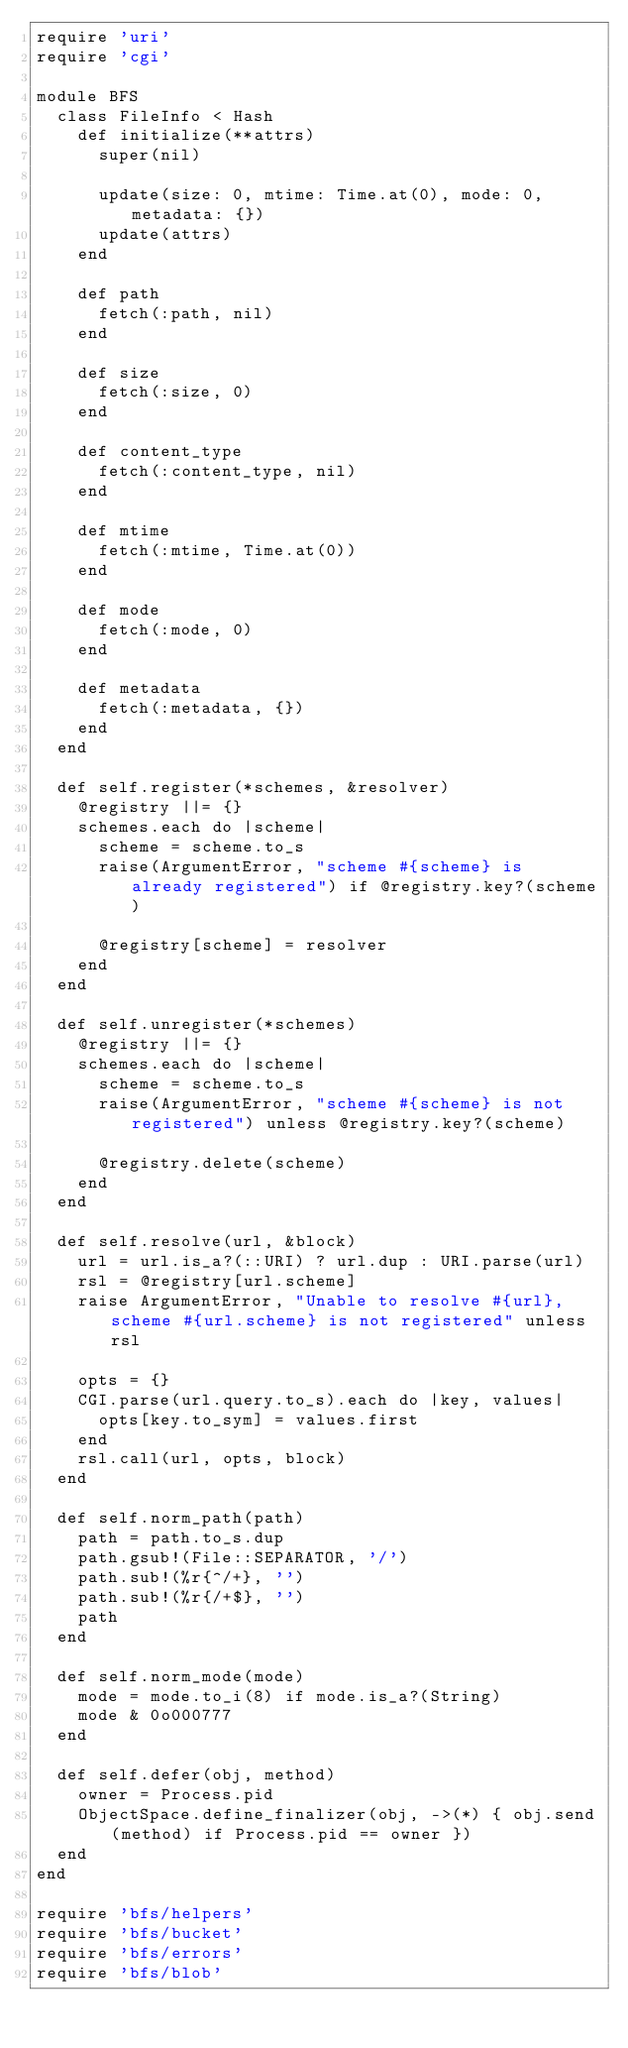<code> <loc_0><loc_0><loc_500><loc_500><_Ruby_>require 'uri'
require 'cgi'

module BFS
  class FileInfo < Hash
    def initialize(**attrs)
      super(nil)

      update(size: 0, mtime: Time.at(0), mode: 0, metadata: {})
      update(attrs)
    end

    def path
      fetch(:path, nil)
    end

    def size
      fetch(:size, 0)
    end

    def content_type
      fetch(:content_type, nil)
    end

    def mtime
      fetch(:mtime, Time.at(0))
    end

    def mode
      fetch(:mode, 0)
    end

    def metadata
      fetch(:metadata, {})
    end
  end

  def self.register(*schemes, &resolver)
    @registry ||= {}
    schemes.each do |scheme|
      scheme = scheme.to_s
      raise(ArgumentError, "scheme #{scheme} is already registered") if @registry.key?(scheme)

      @registry[scheme] = resolver
    end
  end

  def self.unregister(*schemes)
    @registry ||= {}
    schemes.each do |scheme|
      scheme = scheme.to_s
      raise(ArgumentError, "scheme #{scheme} is not registered") unless @registry.key?(scheme)

      @registry.delete(scheme)
    end
  end

  def self.resolve(url, &block)
    url = url.is_a?(::URI) ? url.dup : URI.parse(url)
    rsl = @registry[url.scheme]
    raise ArgumentError, "Unable to resolve #{url}, scheme #{url.scheme} is not registered" unless rsl

    opts = {}
    CGI.parse(url.query.to_s).each do |key, values|
      opts[key.to_sym] = values.first
    end
    rsl.call(url, opts, block)
  end

  def self.norm_path(path)
    path = path.to_s.dup
    path.gsub!(File::SEPARATOR, '/')
    path.sub!(%r{^/+}, '')
    path.sub!(%r{/+$}, '')
    path
  end

  def self.norm_mode(mode)
    mode = mode.to_i(8) if mode.is_a?(String)
    mode & 0o000777
  end

  def self.defer(obj, method)
    owner = Process.pid
    ObjectSpace.define_finalizer(obj, ->(*) { obj.send(method) if Process.pid == owner })
  end
end

require 'bfs/helpers'
require 'bfs/bucket'
require 'bfs/errors'
require 'bfs/blob'
</code> 